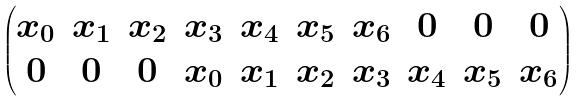<formula> <loc_0><loc_0><loc_500><loc_500>\begin{pmatrix} x _ { 0 } & x _ { 1 } & x _ { 2 } & x _ { 3 } & x _ { 4 } & x _ { 5 } & x _ { 6 } & 0 & 0 & 0 \\ 0 & 0 & 0 & x _ { 0 } & x _ { 1 } & x _ { 2 } & x _ { 3 } & x _ { 4 } & x _ { 5 } & x _ { 6 } \\ \end{pmatrix}</formula> 